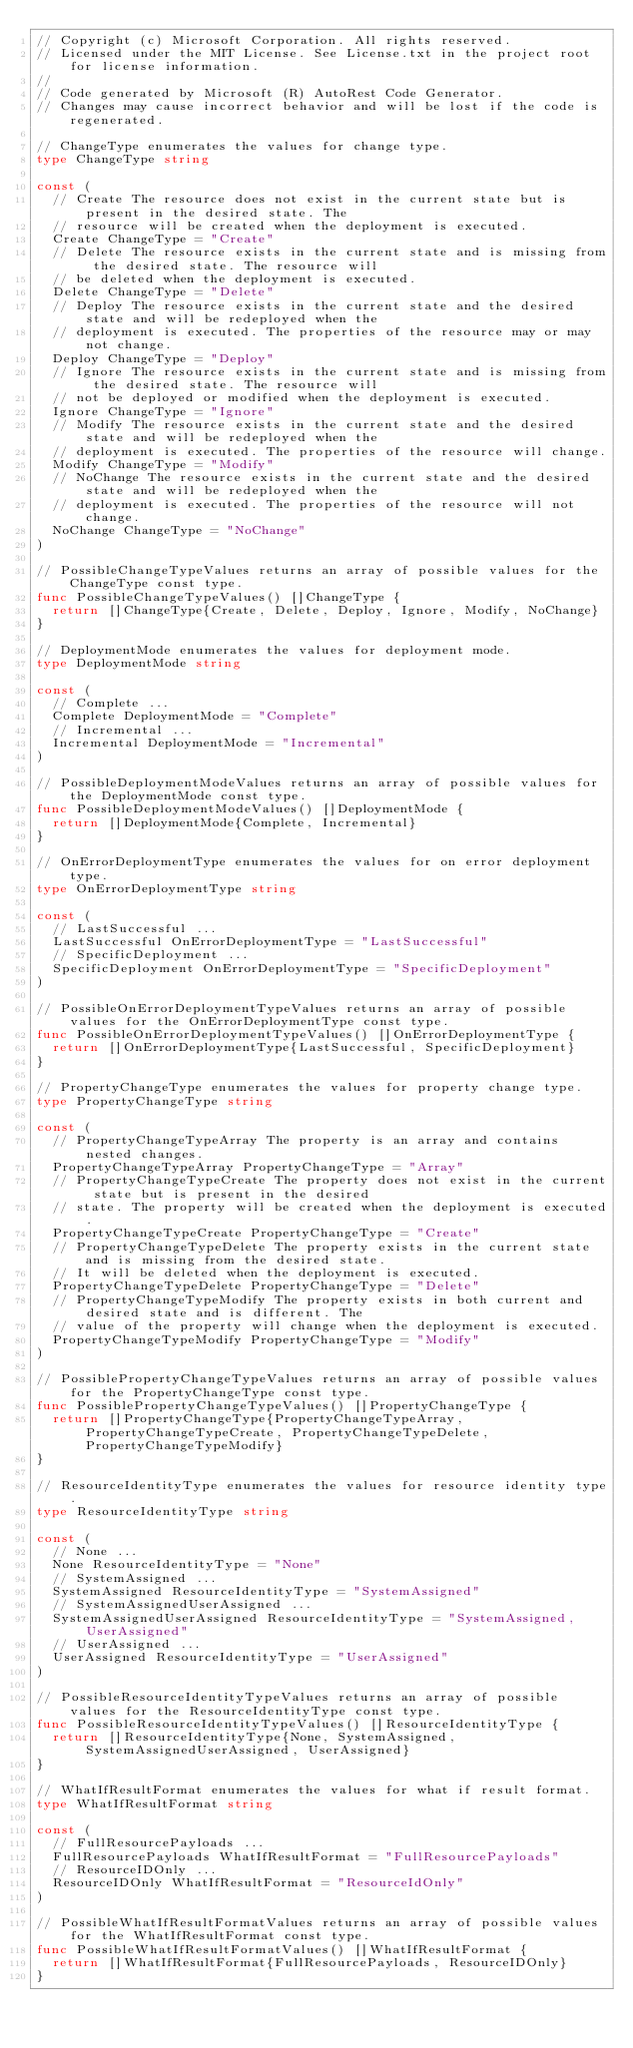Convert code to text. <code><loc_0><loc_0><loc_500><loc_500><_Go_>// Copyright (c) Microsoft Corporation. All rights reserved.
// Licensed under the MIT License. See License.txt in the project root for license information.
//
// Code generated by Microsoft (R) AutoRest Code Generator.
// Changes may cause incorrect behavior and will be lost if the code is regenerated.

// ChangeType enumerates the values for change type.
type ChangeType string

const (
	// Create The resource does not exist in the current state but is present in the desired state. The
	// resource will be created when the deployment is executed.
	Create ChangeType = "Create"
	// Delete The resource exists in the current state and is missing from the desired state. The resource will
	// be deleted when the deployment is executed.
	Delete ChangeType = "Delete"
	// Deploy The resource exists in the current state and the desired state and will be redeployed when the
	// deployment is executed. The properties of the resource may or may not change.
	Deploy ChangeType = "Deploy"
	// Ignore The resource exists in the current state and is missing from the desired state. The resource will
	// not be deployed or modified when the deployment is executed.
	Ignore ChangeType = "Ignore"
	// Modify The resource exists in the current state and the desired state and will be redeployed when the
	// deployment is executed. The properties of the resource will change.
	Modify ChangeType = "Modify"
	// NoChange The resource exists in the current state and the desired state and will be redeployed when the
	// deployment is executed. The properties of the resource will not change.
	NoChange ChangeType = "NoChange"
)

// PossibleChangeTypeValues returns an array of possible values for the ChangeType const type.
func PossibleChangeTypeValues() []ChangeType {
	return []ChangeType{Create, Delete, Deploy, Ignore, Modify, NoChange}
}

// DeploymentMode enumerates the values for deployment mode.
type DeploymentMode string

const (
	// Complete ...
	Complete DeploymentMode = "Complete"
	// Incremental ...
	Incremental DeploymentMode = "Incremental"
)

// PossibleDeploymentModeValues returns an array of possible values for the DeploymentMode const type.
func PossibleDeploymentModeValues() []DeploymentMode {
	return []DeploymentMode{Complete, Incremental}
}

// OnErrorDeploymentType enumerates the values for on error deployment type.
type OnErrorDeploymentType string

const (
	// LastSuccessful ...
	LastSuccessful OnErrorDeploymentType = "LastSuccessful"
	// SpecificDeployment ...
	SpecificDeployment OnErrorDeploymentType = "SpecificDeployment"
)

// PossibleOnErrorDeploymentTypeValues returns an array of possible values for the OnErrorDeploymentType const type.
func PossibleOnErrorDeploymentTypeValues() []OnErrorDeploymentType {
	return []OnErrorDeploymentType{LastSuccessful, SpecificDeployment}
}

// PropertyChangeType enumerates the values for property change type.
type PropertyChangeType string

const (
	// PropertyChangeTypeArray The property is an array and contains nested changes.
	PropertyChangeTypeArray PropertyChangeType = "Array"
	// PropertyChangeTypeCreate The property does not exist in the current state but is present in the desired
	// state. The property will be created when the deployment is executed.
	PropertyChangeTypeCreate PropertyChangeType = "Create"
	// PropertyChangeTypeDelete The property exists in the current state and is missing from the desired state.
	// It will be deleted when the deployment is executed.
	PropertyChangeTypeDelete PropertyChangeType = "Delete"
	// PropertyChangeTypeModify The property exists in both current and desired state and is different. The
	// value of the property will change when the deployment is executed.
	PropertyChangeTypeModify PropertyChangeType = "Modify"
)

// PossiblePropertyChangeTypeValues returns an array of possible values for the PropertyChangeType const type.
func PossiblePropertyChangeTypeValues() []PropertyChangeType {
	return []PropertyChangeType{PropertyChangeTypeArray, PropertyChangeTypeCreate, PropertyChangeTypeDelete, PropertyChangeTypeModify}
}

// ResourceIdentityType enumerates the values for resource identity type.
type ResourceIdentityType string

const (
	// None ...
	None ResourceIdentityType = "None"
	// SystemAssigned ...
	SystemAssigned ResourceIdentityType = "SystemAssigned"
	// SystemAssignedUserAssigned ...
	SystemAssignedUserAssigned ResourceIdentityType = "SystemAssigned, UserAssigned"
	// UserAssigned ...
	UserAssigned ResourceIdentityType = "UserAssigned"
)

// PossibleResourceIdentityTypeValues returns an array of possible values for the ResourceIdentityType const type.
func PossibleResourceIdentityTypeValues() []ResourceIdentityType {
	return []ResourceIdentityType{None, SystemAssigned, SystemAssignedUserAssigned, UserAssigned}
}

// WhatIfResultFormat enumerates the values for what if result format.
type WhatIfResultFormat string

const (
	// FullResourcePayloads ...
	FullResourcePayloads WhatIfResultFormat = "FullResourcePayloads"
	// ResourceIDOnly ...
	ResourceIDOnly WhatIfResultFormat = "ResourceIdOnly"
)

// PossibleWhatIfResultFormatValues returns an array of possible values for the WhatIfResultFormat const type.
func PossibleWhatIfResultFormatValues() []WhatIfResultFormat {
	return []WhatIfResultFormat{FullResourcePayloads, ResourceIDOnly}
}
</code> 